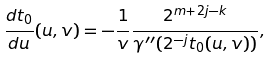Convert formula to latex. <formula><loc_0><loc_0><loc_500><loc_500>\frac { d t _ { 0 } } { d u } ( u , v ) = - \frac { 1 } { v } \frac { 2 ^ { m + 2 j - k } } { \gamma ^ { \prime \prime } ( 2 ^ { - j } t _ { 0 } ( u , v ) ) } ,</formula> 